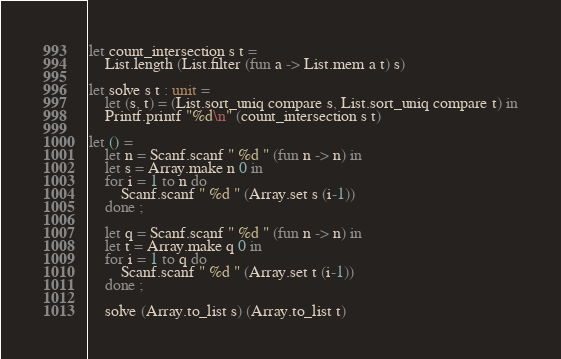Convert code to text. <code><loc_0><loc_0><loc_500><loc_500><_OCaml_>let count_intersection s t =
    List.length (List.filter (fun a -> List.mem a t) s)

let solve s t : unit =
    let (s, t) = (List.sort_uniq compare s, List.sort_uniq compare t) in
    Printf.printf "%d\n" (count_intersection s t)

let () =
    let n = Scanf.scanf " %d " (fun n -> n) in
    let s = Array.make n 0 in
    for i = 1 to n do
        Scanf.scanf " %d " (Array.set s (i-1))
    done ;

    let q = Scanf.scanf " %d " (fun n -> n) in
    let t = Array.make q 0 in
    for i = 1 to q do
        Scanf.scanf " %d " (Array.set t (i-1))
    done ;

    solve (Array.to_list s) (Array.to_list t)</code> 